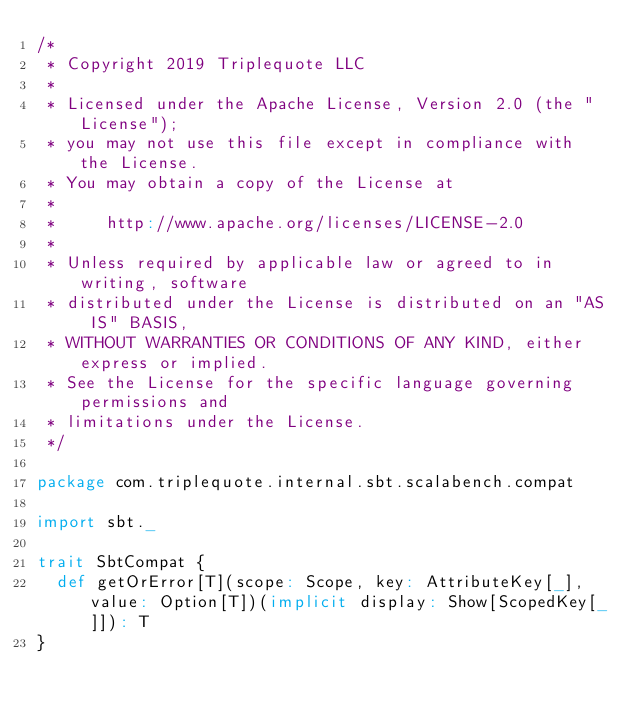<code> <loc_0><loc_0><loc_500><loc_500><_Scala_>/*
 * Copyright 2019 Triplequote LLC
 *
 * Licensed under the Apache License, Version 2.0 (the "License");
 * you may not use this file except in compliance with the License.
 * You may obtain a copy of the License at
 *
 *     http://www.apache.org/licenses/LICENSE-2.0
 *
 * Unless required by applicable law or agreed to in writing, software
 * distributed under the License is distributed on an "AS IS" BASIS,
 * WITHOUT WARRANTIES OR CONDITIONS OF ANY KIND, either express or implied.
 * See the License for the specific language governing permissions and
 * limitations under the License.
 */

package com.triplequote.internal.sbt.scalabench.compat

import sbt._

trait SbtCompat {
  def getOrError[T](scope: Scope, key: AttributeKey[_], value: Option[T])(implicit display: Show[ScopedKey[_]]): T
}
</code> 